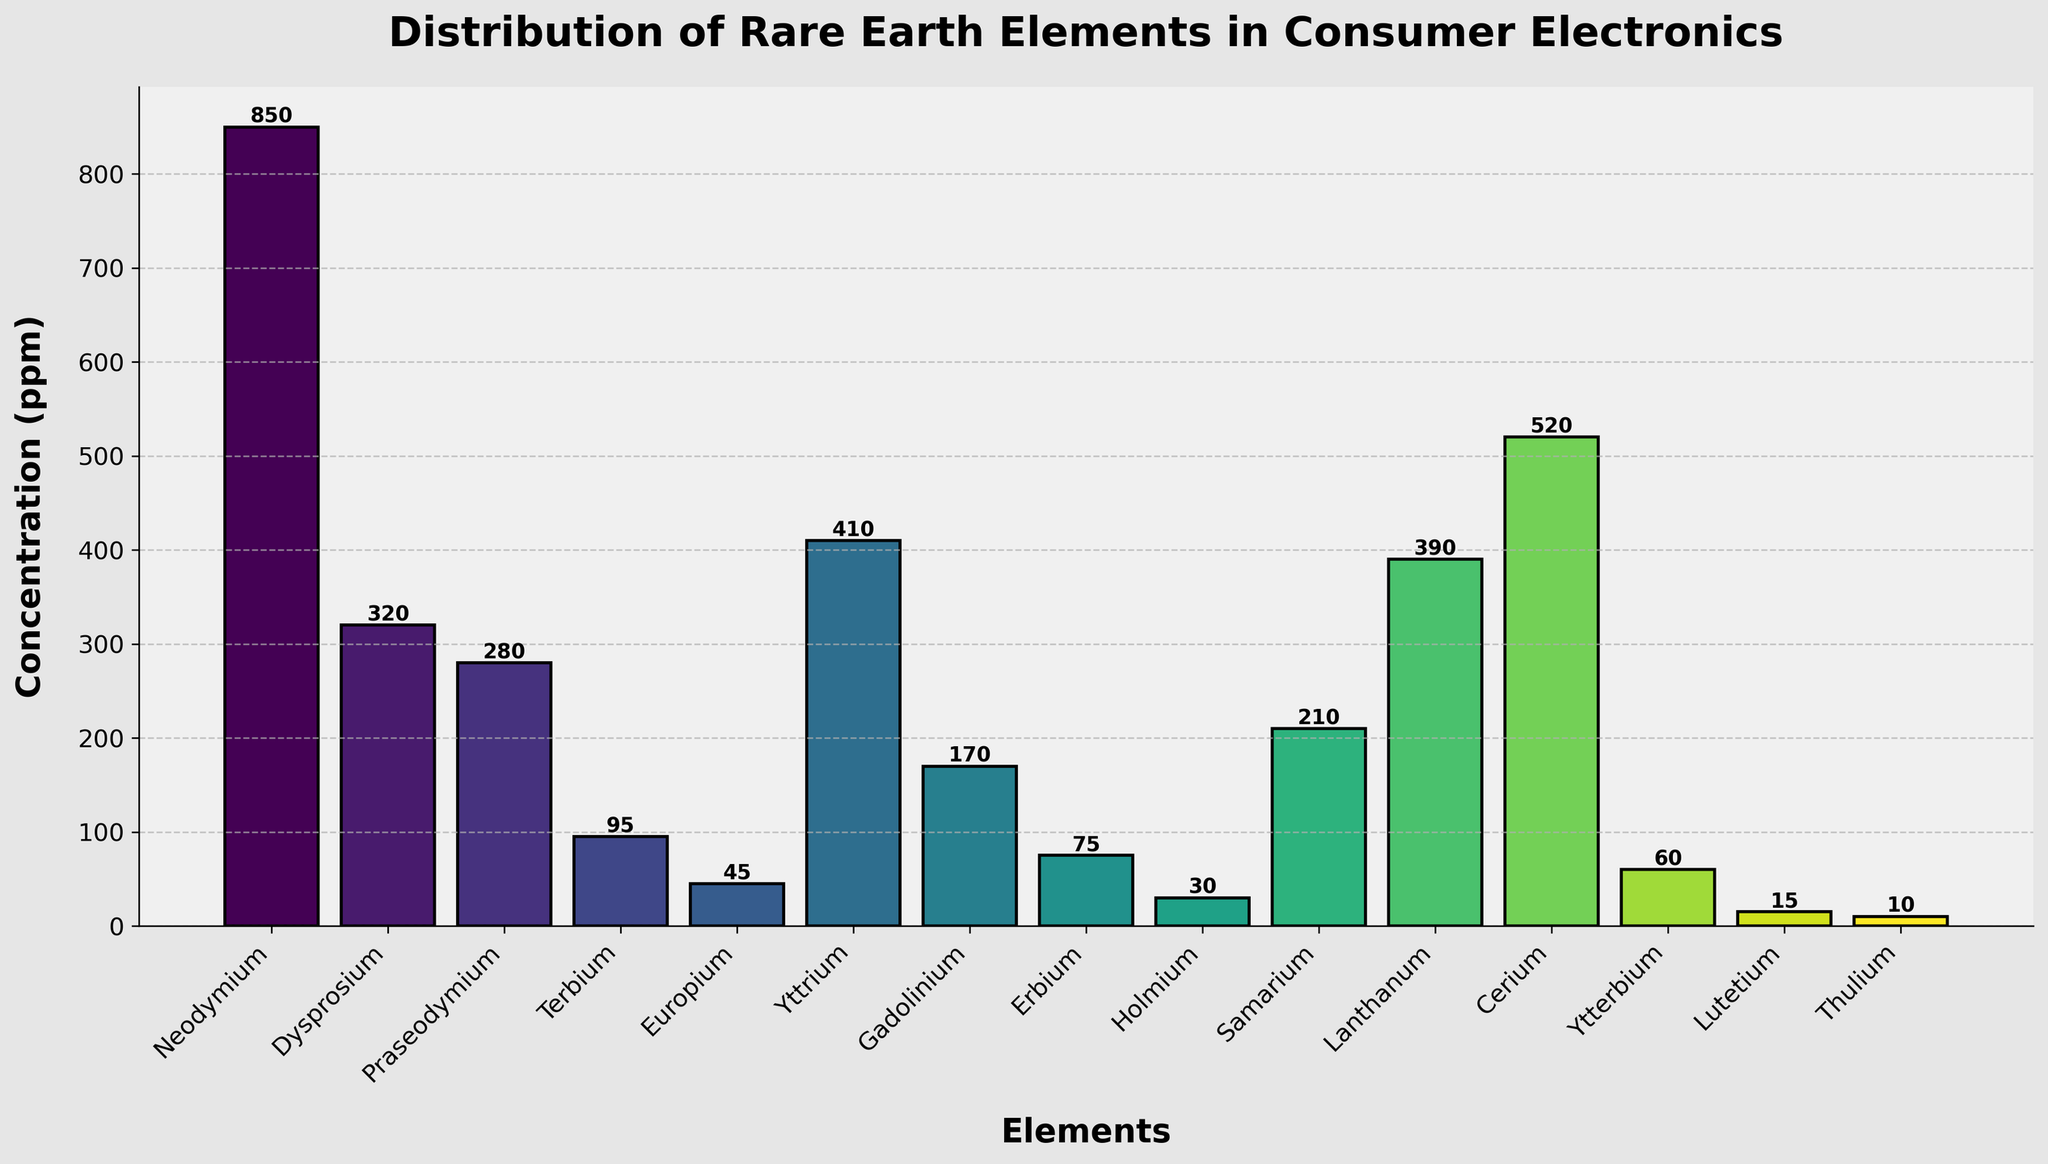Which element has the highest concentration? The bar representing Neodymium is the tallest, indicating it has the highest concentration among all the elements.
Answer: Neodymium What is the difference in concentration between Neodymium and Cerium? Neodymium's concentration is 850 ppm, and Cerium's concentration is 520 ppm. The difference is 850 - 520 = 330 ppm.
Answer: 330 ppm Which three elements have the lowest concentrations? The three shortest bars represent Thulium, Lutetium, and Holmium, indicating their concentrations are the lowest among all the elements.
Answer: Thulium, Lutetium, Holmium Which element has a concentration exactly between Dysprosium and Lanthanum? Dysprosium's concentration is 320 ppm and Lanthanum's is 390 ppm. The average is (320 + 390) / 2 = 355 ppm. Yttrium, with a concentration of 410 ppm, is closest to this value.
Answer: Yttrium How many elements have a concentration greater than 200 ppm? Neodymium, Dysprosium, Praseodymium, Yttrium, Samarium, Lanthanum, and Cerium each have concentrations greater than 200 ppm. There are 7 such elements.
Answer: 7 Which element has a concentration closest to the average concentration of all listed elements? First, find the average concentration: (850 + 320 + 280 + 95 + 45 + 410 + 170 + 75 + 30 + 210 + 390 + 520 + 60 + 15 + 10) / 15 = 243 ppm. Praseodymium, with a concentration of 280 ppm, is the closest to this average.
Answer: Praseodymium What is the combined concentration of the five most abundant elements? The five most abundant elements are Neodymium (850 ppm), Cerium (520 ppm), Lanthanum (390 ppm), Yttrium (410 ppm), and Dysprosium (320 ppm). Their combined concentration is 850 + 520 + 390 + 410 + 320 = 2,490 ppm.
Answer: 2,490 ppm Is the concentration of Europium more or less than half the concentration of Praseodymium? Europium has a concentration of 45 ppm, and Praseodymium has a concentration of 280 ppm. Half of Praseodymium’s concentration is 280 / 2 = 140 ppm. Since 45 ppm is less than 140 ppm, Europium's concentration is less than half of Praseodymium’s.
Answer: Less Which elements have a lower concentration than Ytterbium but higher than Thulium? Thulium has a concentration of 10 ppm, and Ytterbium has 60 ppm. Elements with concentrations between 10 and 60 ppm are Lutetium (15 ppm) and Holmium (30 ppm).
Answer: Lutetium, Holmium 